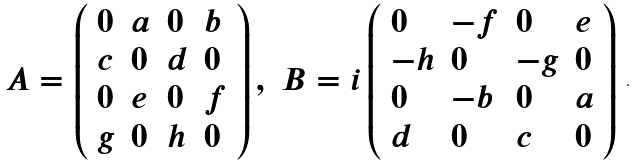<formula> <loc_0><loc_0><loc_500><loc_500>\begin{array} { l l } { { A = \left ( \begin{array} { l l l l } { 0 } & { a } & { 0 } & { b } \\ { c } & { 0 } & { d } & { 0 } \\ { 0 } & { e } & { 0 } & { f } \\ { g } & { 0 } & { h } & { 0 } \end{array} \right ) , } } & { { B = i \left ( \begin{array} { l l l l } { 0 } & { - f } & { 0 } & { e } \\ { - h } & { 0 } & { - g } & { 0 } \\ { 0 } & { - b } & { 0 } & { a } \\ { d } & { 0 } & { c } & { 0 } \end{array} \right ) } } \end{array} .</formula> 